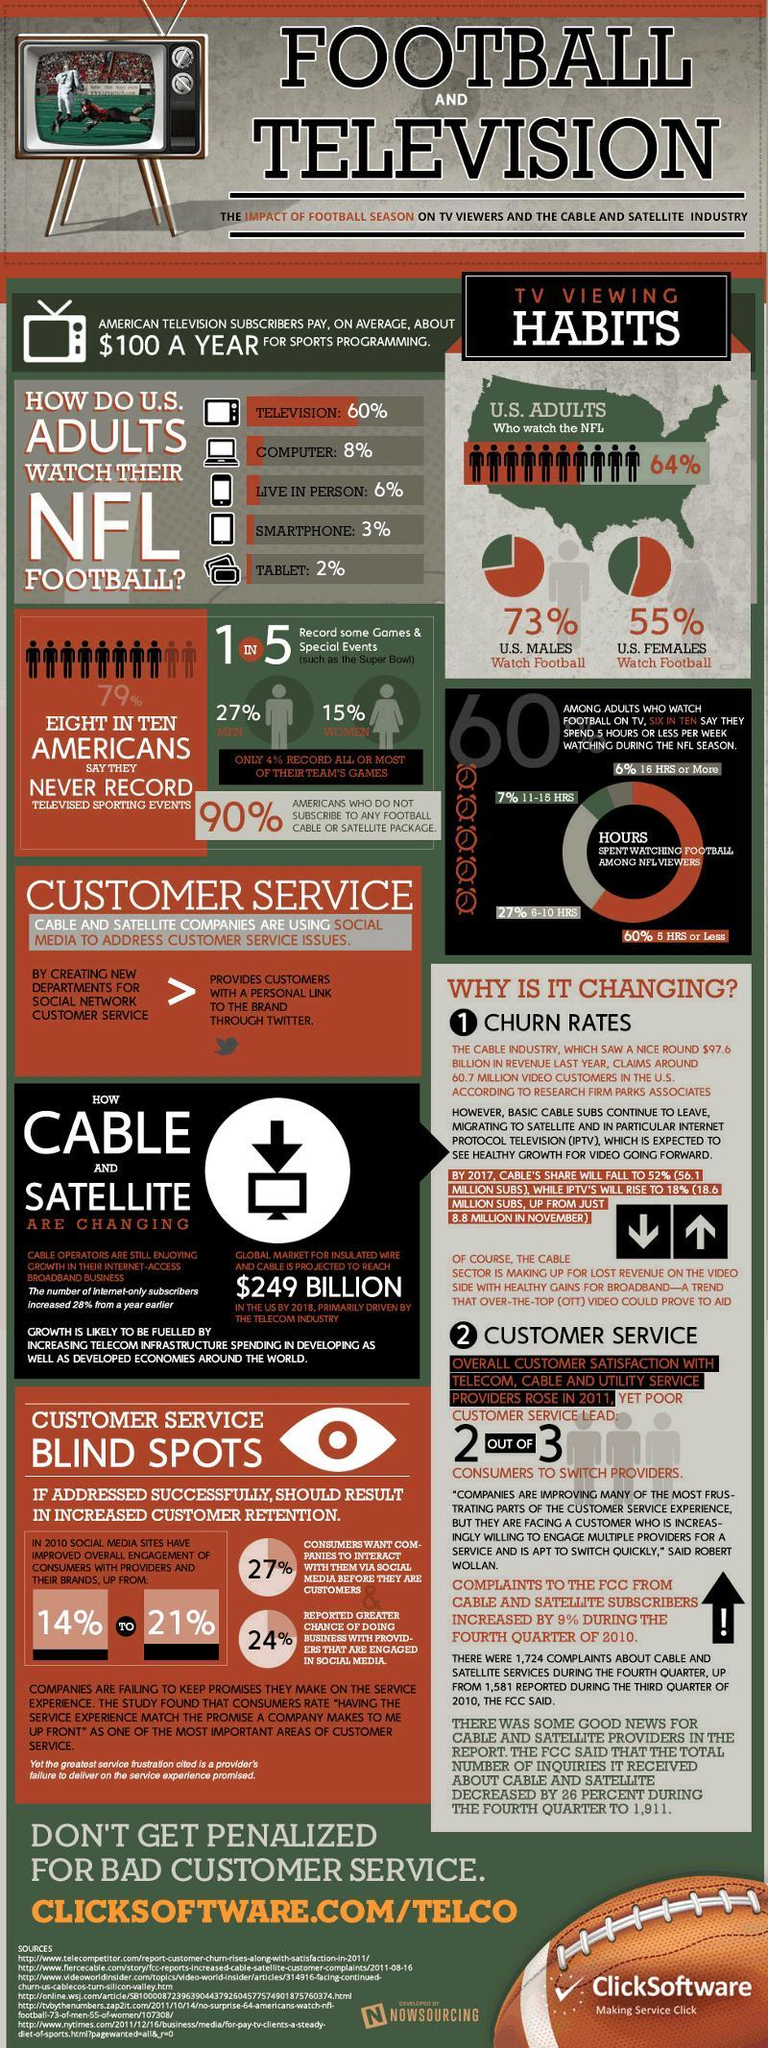Which is the least preferred device to watch NFL?
Answer the question with a short phrase. TABLET Who in the US watch football more - males or females? U.S. MALES What percent of US adults do not watch the NFL? 36% How many sources are listed at the bottom? 6 What percent of adults spend more than 10 hours watching during the NFL season? 13% What percent of U.S. females do not watch football? 45% How many out of five persons do not record some games and special events? 4 IN 5 By what percent has social media sites improved overall engagement of consumers with providers and brands in 2010? 7% 